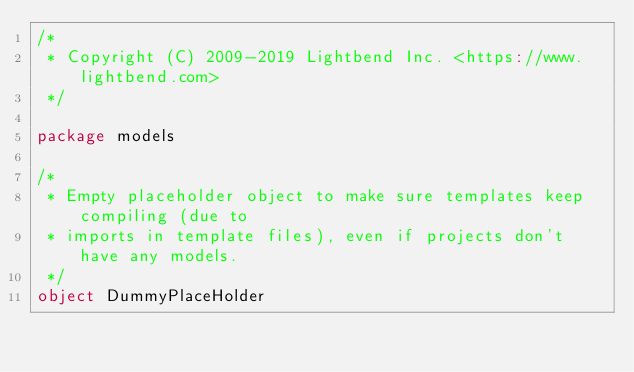Convert code to text. <code><loc_0><loc_0><loc_500><loc_500><_Scala_>/*
 * Copyright (C) 2009-2019 Lightbend Inc. <https://www.lightbend.com>
 */

package models

/*
 * Empty placeholder object to make sure templates keep compiling (due to
 * imports in template files), even if projects don't have any models.
 */
object DummyPlaceHolder
</code> 